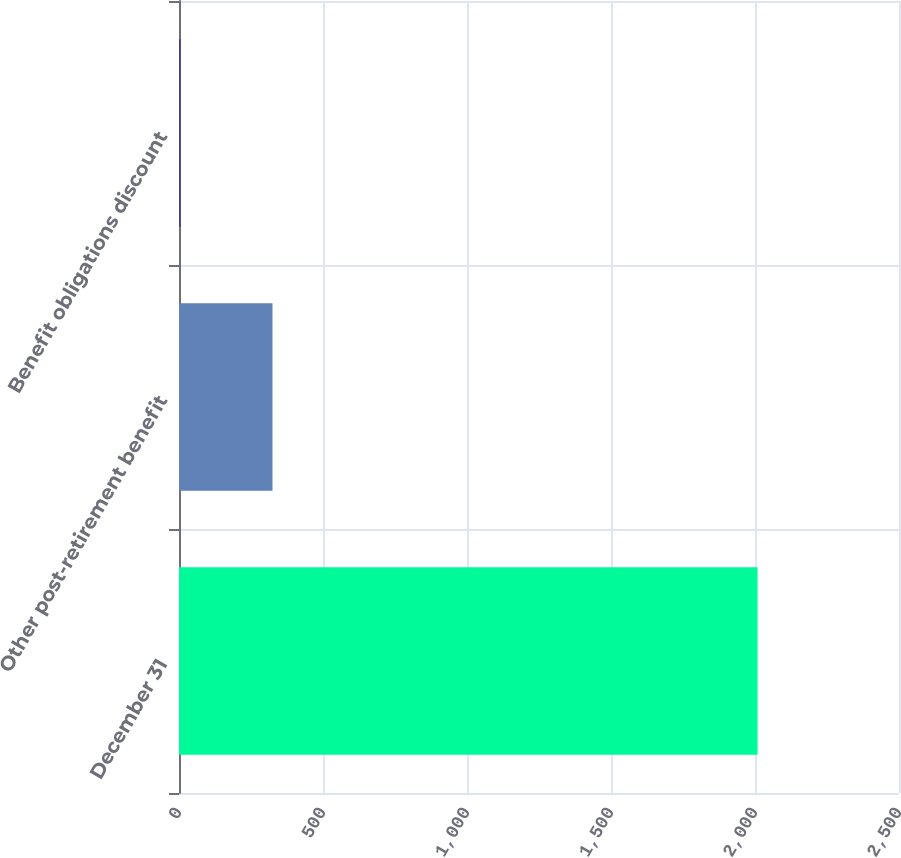<chart> <loc_0><loc_0><loc_500><loc_500><bar_chart><fcel>December 31<fcel>Other post-retirement benefit<fcel>Benefit obligations discount<nl><fcel>2009<fcel>324.6<fcel>5.7<nl></chart> 